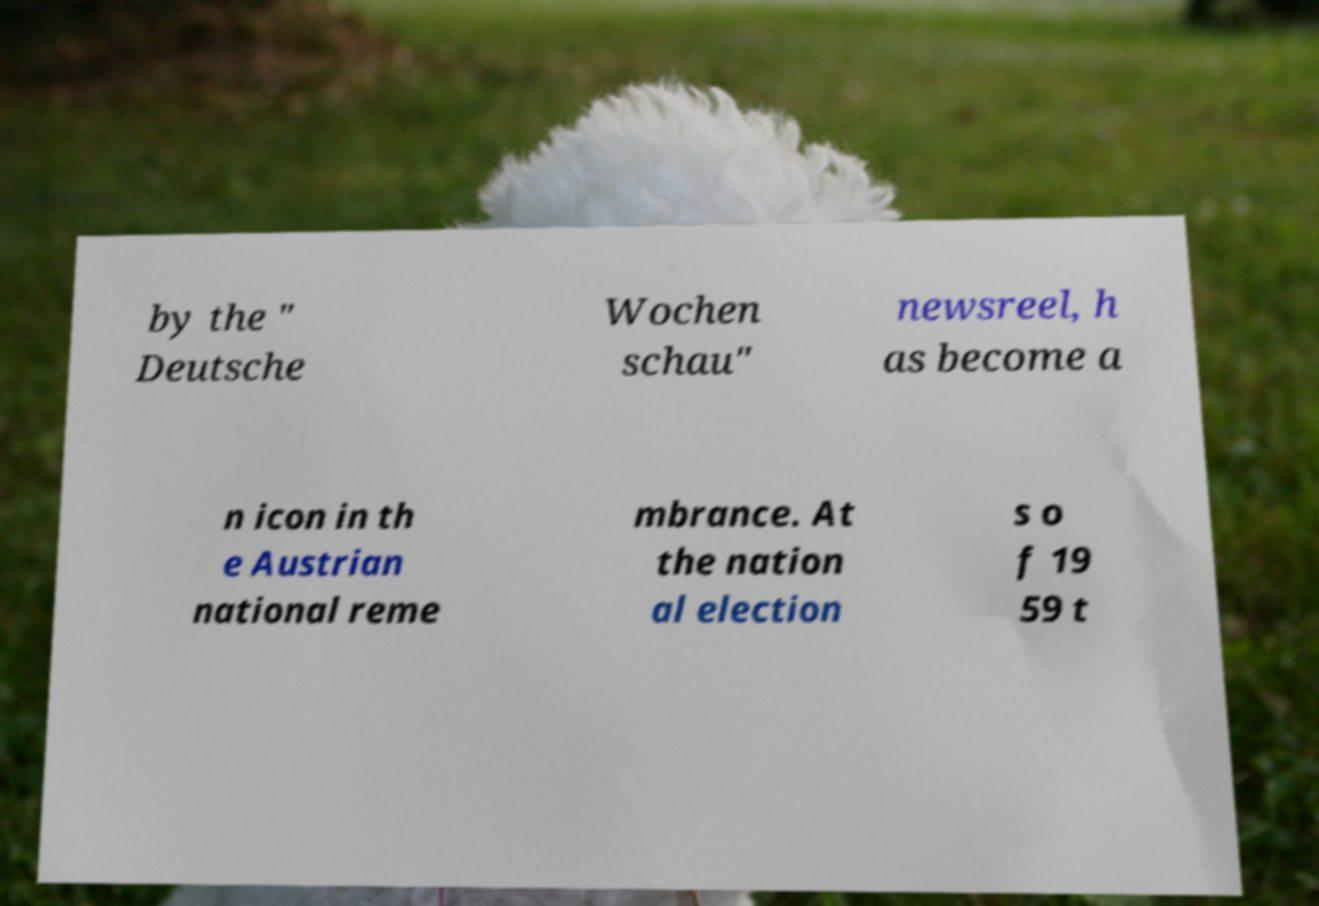For documentation purposes, I need the text within this image transcribed. Could you provide that? by the " Deutsche Wochen schau" newsreel, h as become a n icon in th e Austrian national reme mbrance. At the nation al election s o f 19 59 t 